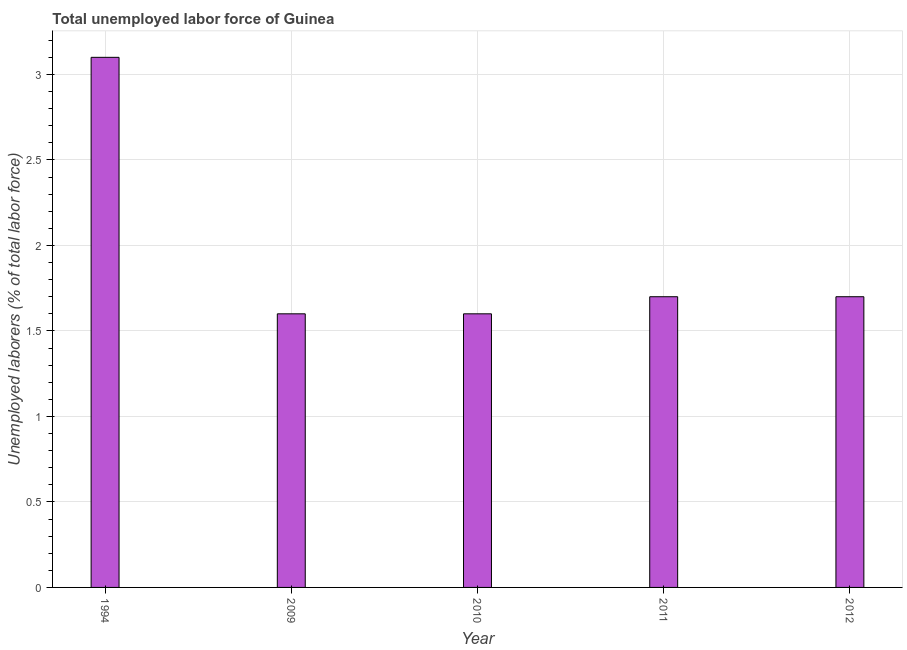What is the title of the graph?
Provide a short and direct response. Total unemployed labor force of Guinea. What is the label or title of the Y-axis?
Your answer should be very brief. Unemployed laborers (% of total labor force). What is the total unemployed labour force in 1994?
Offer a terse response. 3.1. Across all years, what is the maximum total unemployed labour force?
Your answer should be compact. 3.1. Across all years, what is the minimum total unemployed labour force?
Keep it short and to the point. 1.6. What is the sum of the total unemployed labour force?
Offer a very short reply. 9.7. What is the average total unemployed labour force per year?
Give a very brief answer. 1.94. What is the median total unemployed labour force?
Your answer should be very brief. 1.7. What is the ratio of the total unemployed labour force in 1994 to that in 2011?
Give a very brief answer. 1.82. Is the total unemployed labour force in 2009 less than that in 2011?
Offer a terse response. Yes. What is the difference between the highest and the second highest total unemployed labour force?
Provide a short and direct response. 1.4. Is the sum of the total unemployed labour force in 1994 and 2012 greater than the maximum total unemployed labour force across all years?
Make the answer very short. Yes. What is the difference between the highest and the lowest total unemployed labour force?
Your answer should be very brief. 1.5. In how many years, is the total unemployed labour force greater than the average total unemployed labour force taken over all years?
Your answer should be very brief. 1. How many bars are there?
Make the answer very short. 5. What is the Unemployed laborers (% of total labor force) in 1994?
Keep it short and to the point. 3.1. What is the Unemployed laborers (% of total labor force) of 2009?
Your answer should be very brief. 1.6. What is the Unemployed laborers (% of total labor force) of 2010?
Keep it short and to the point. 1.6. What is the Unemployed laborers (% of total labor force) in 2011?
Offer a very short reply. 1.7. What is the Unemployed laborers (% of total labor force) of 2012?
Your answer should be very brief. 1.7. What is the difference between the Unemployed laborers (% of total labor force) in 1994 and 2009?
Make the answer very short. 1.5. What is the difference between the Unemployed laborers (% of total labor force) in 1994 and 2012?
Ensure brevity in your answer.  1.4. What is the difference between the Unemployed laborers (% of total labor force) in 2010 and 2011?
Give a very brief answer. -0.1. What is the difference between the Unemployed laborers (% of total labor force) in 2010 and 2012?
Your answer should be very brief. -0.1. What is the ratio of the Unemployed laborers (% of total labor force) in 1994 to that in 2009?
Ensure brevity in your answer.  1.94. What is the ratio of the Unemployed laborers (% of total labor force) in 1994 to that in 2010?
Provide a succinct answer. 1.94. What is the ratio of the Unemployed laborers (% of total labor force) in 1994 to that in 2011?
Provide a succinct answer. 1.82. What is the ratio of the Unemployed laborers (% of total labor force) in 1994 to that in 2012?
Offer a very short reply. 1.82. What is the ratio of the Unemployed laborers (% of total labor force) in 2009 to that in 2010?
Offer a terse response. 1. What is the ratio of the Unemployed laborers (% of total labor force) in 2009 to that in 2011?
Your answer should be very brief. 0.94. What is the ratio of the Unemployed laborers (% of total labor force) in 2009 to that in 2012?
Make the answer very short. 0.94. What is the ratio of the Unemployed laborers (% of total labor force) in 2010 to that in 2011?
Provide a short and direct response. 0.94. What is the ratio of the Unemployed laborers (% of total labor force) in 2010 to that in 2012?
Your response must be concise. 0.94. 